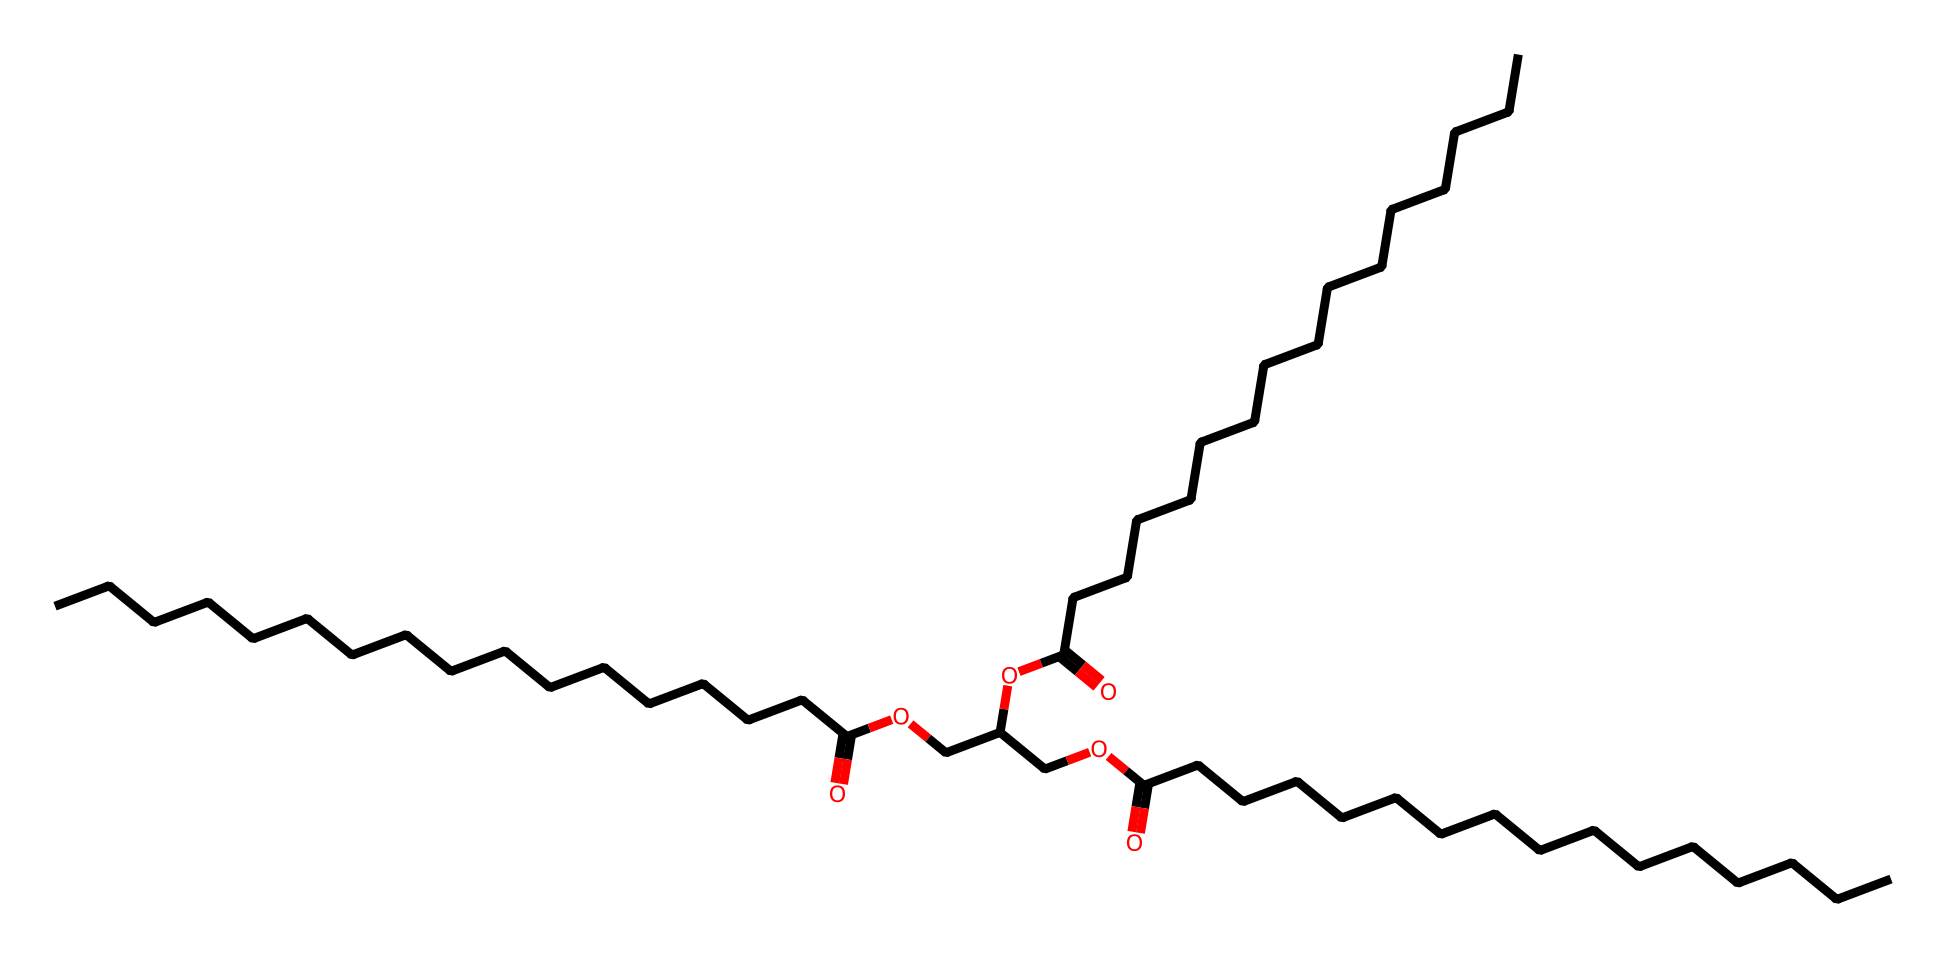What is the total number of carbon atoms in this molecule? By analyzing the SMILES representation, we can count the number of 'C' letters, which denote carbon atoms. The structure shows numerous 'CCCC' sequences alongside those connected to functional groups, leading to a total count of 34 carbon atoms.
Answer: 34 How many oxygen atoms are present in this chemical structure? In the SMILES string, we look for the letter 'O', indicating oxygen atoms. Upon reviewing the representation, we see 'O' appearing several times, totaling 6 oxygen atoms in the entire molecule.
Answer: 6 What type of functional group is indicated by the 'COOH' portion of the SMILES? The presence of the 'C(=O)O' portion in the structure signifies a carboxylic acid functional group, as the 'C' is double-bonded to 'O' and single-bonded to another 'O'. This indicates it has acidic properties characteristic of carboxylic acids.
Answer: carboxylic acid Is this molecule likely to be hydrophobic or hydrophilic, and why? The molecule features long carbon chains typical of surfactants, indicating a strong hydrophobic character; however, the presence of multiple polar functional groups (specifically the carboxylic acids and esters) suggests some hydrophilic properties, enabling it to interact with water. Thus, it is amphiphilic.
Answer: amphiphilic What aspect of the structure contributes to its use as a dispersant for oil spills? The long hydrocarbon chains provide a hydrophobic character for interacting with oil, while the polar head (carboxylic acids) helps to solubilize the oil in water. This dual functionality is crucial for the dispersal of oil in water, ultimately aiding in spill remediation.
Answer: dual functionality How many ester linkages are observable in the molecular structure? By examining the SMILES, we identify the 'C(=O)O' pattern to find ester linkages. The molecule contains three separate 'C(=O)O' patterns scattered within its structure, indicating three ester connections in total.
Answer: 3 What role do the long carbon chains play in the performance of this dispersant? The long carbon chains enhance the dispersant's ability to interact with and encapsulate oil droplets due to their hydrophobic nature. This allows the dispersant to effectively reduce surface tension, facilitating better mixing of oil into water.
Answer: interact with oil droplets 